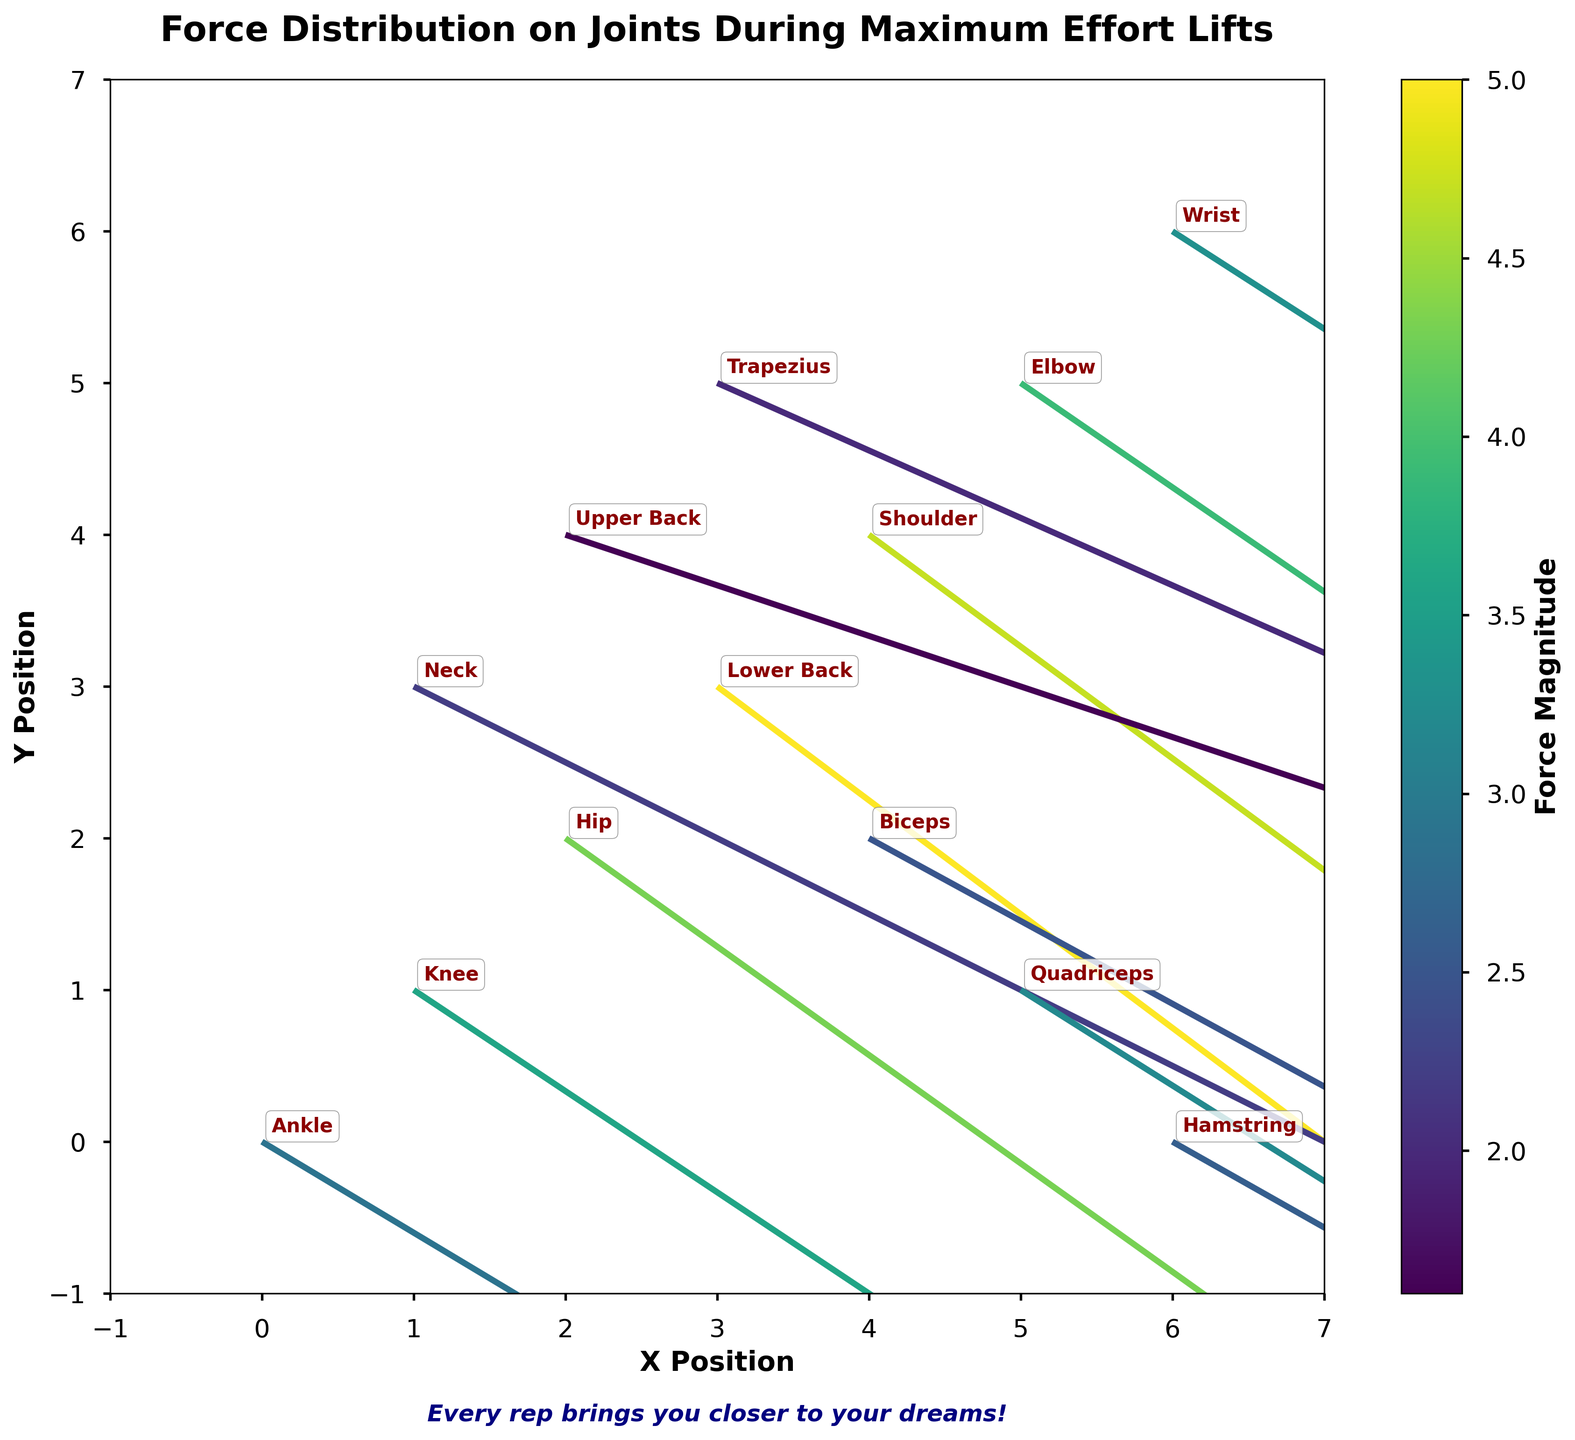What is the title of the plot? The title is located at the top of the plot and provides a summary of what the figure represents.
Answer: Force Distribution on Joints During Maximum Effort Lifts What variable does the color represent? The legend in the form of a color bar on the right side of the plot indicates that the color represents force magnitude.
Answer: Force magnitude How many joints are visualized in the figure? By counting the number of distinct annotations on the plot, we can determine the number of joints visualized.
Answer: 13 Which joint has the highest force magnitude? The color bar shows the mapping of colors to force magnitude. By identifying the vector with the color representing the highest magnitude, we see that the 'Lower Back' has the highest force magnitude.
Answer: Lower Back What are the x and y positions for the 'Shoulder' joint? By looking at the annotation for 'Shoulder', we see that it's positioned at the coordinate (4, 4).
Answer: (4, 4) What is the direction of the force vector acting on the 'Knee'? The force vector is represented by an arrow, and its components are given by (3.0, -2.0). This indicates a force directed more to the right and downward.
Answer: Right and downward How does the force magnitude of the 'Hip' compare to the 'Knee'? By comparing the colors representing the magnitudes of 'Hip' and 'Knee', we see that 'Hip' has a darker color indicating a higher magnitude. The numeric values also confirm that 'Hip's magnitude (4.3) is greater than 'Knee's magnitude (3.6).
Answer: Hip has a higher force magnitude than Knee What is the average force magnitude on all joints? To find the average, we sum up the magnitudes and then divide by the number of joints. Sum = 2.9 + 3.6 + 4.3 + 5.0 + 4.7 + 3.9 + 3.3 + 2.2 + 1.6 + 2.0 + 2.5 + 3.2 + 2.6 = 41.8. Number of joints = 13. Average = 41.8 / 13 ≈ 3.22
Answer: 3.22 Which joints have force vectors directed predominantly downward? By analyzing the direction vectors (u, v), vectors with negative v values indicate downward direction. Joints with this characteristic are Ankle, Knee, Hip, Lower Back, Shoulder, Elbow, Wrist, Neck, Upper Back, Trapezius, Biceps, Quadriceps, Hamstring.
Answer: Ankle, Knee, Hip, Lower Back, Shoulder, Elbow, Wrist, Neck, Upper Back, Trapezius, Biceps, Quadriceps, Hamstring 